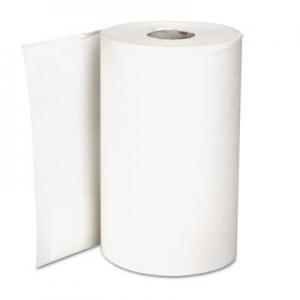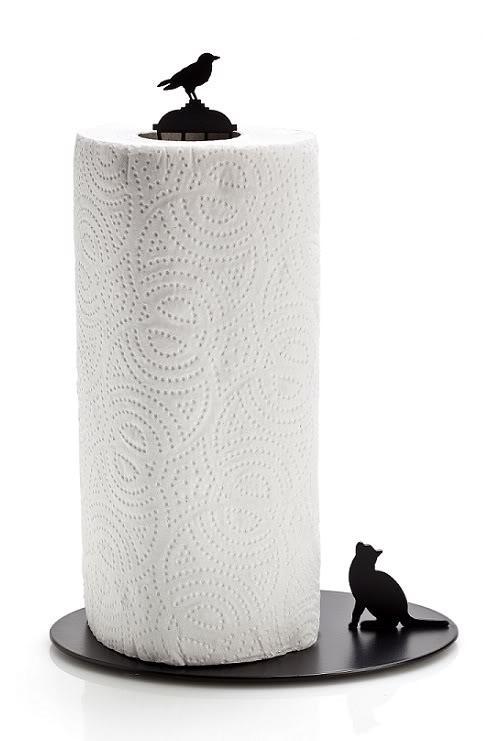The first image is the image on the left, the second image is the image on the right. Analyze the images presented: Is the assertion "Only one roll is shown on a stand holder." valid? Answer yes or no. Yes. 